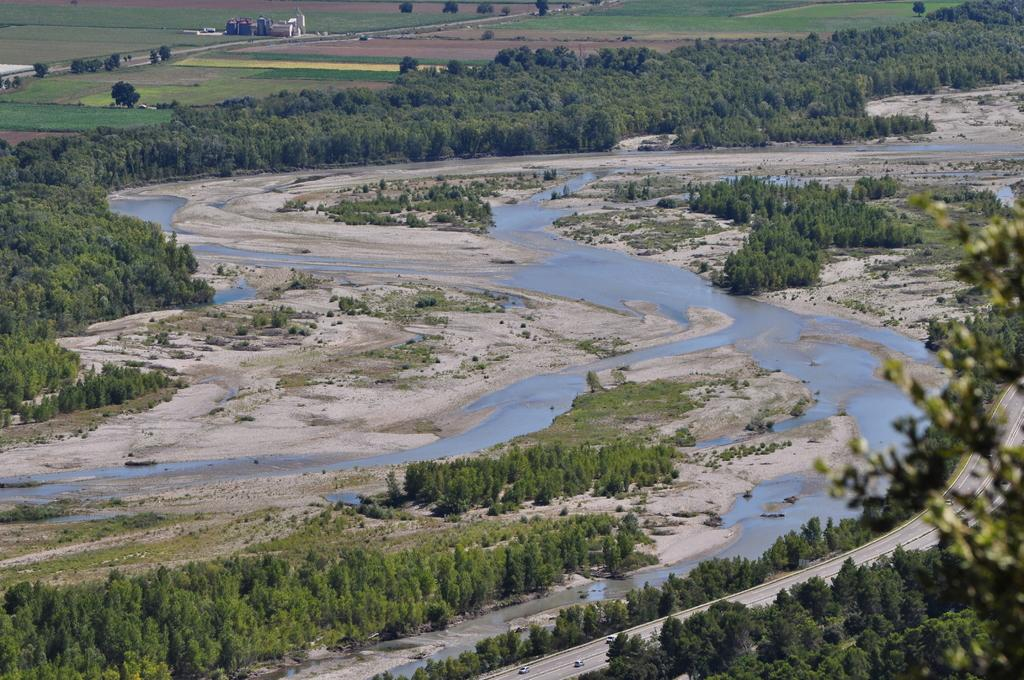What is the primary element visible in the image? There is water in the image. What type of natural vegetation can be seen in the image? There are trees in the image. What type of man-made structures are visible in the image? There are houses in the background of the image. What type of transportation is present in the image? There are vehicles on the road in the image. Can you tell me how many cacti are visible in the image? There are no cacti present in the image. What is the daughter doing in the image? There is no daughter present in the image. 